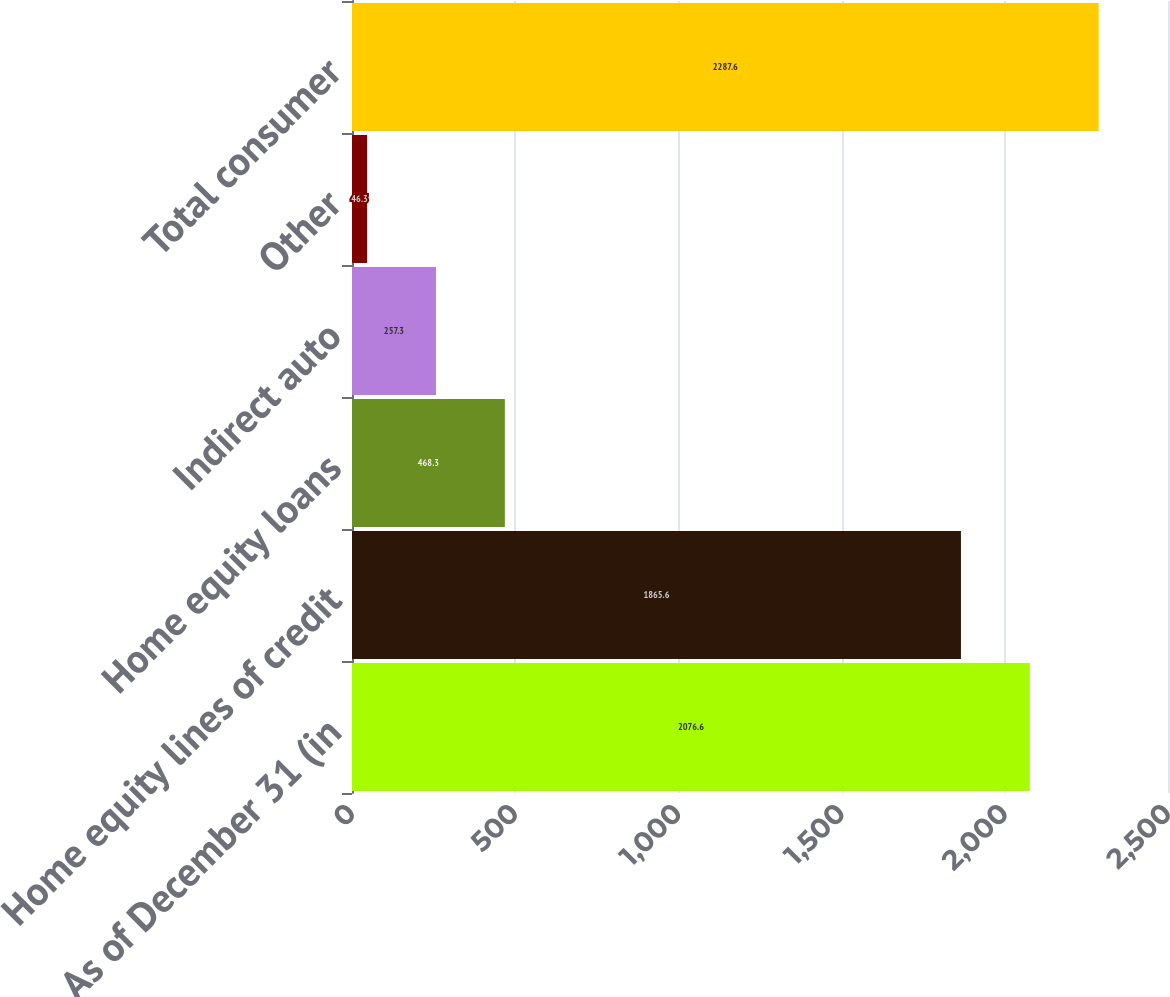Convert chart. <chart><loc_0><loc_0><loc_500><loc_500><bar_chart><fcel>As of December 31 (in<fcel>Home equity lines of credit<fcel>Home equity loans<fcel>Indirect auto<fcel>Other<fcel>Total consumer<nl><fcel>2076.6<fcel>1865.6<fcel>468.3<fcel>257.3<fcel>46.3<fcel>2287.6<nl></chart> 